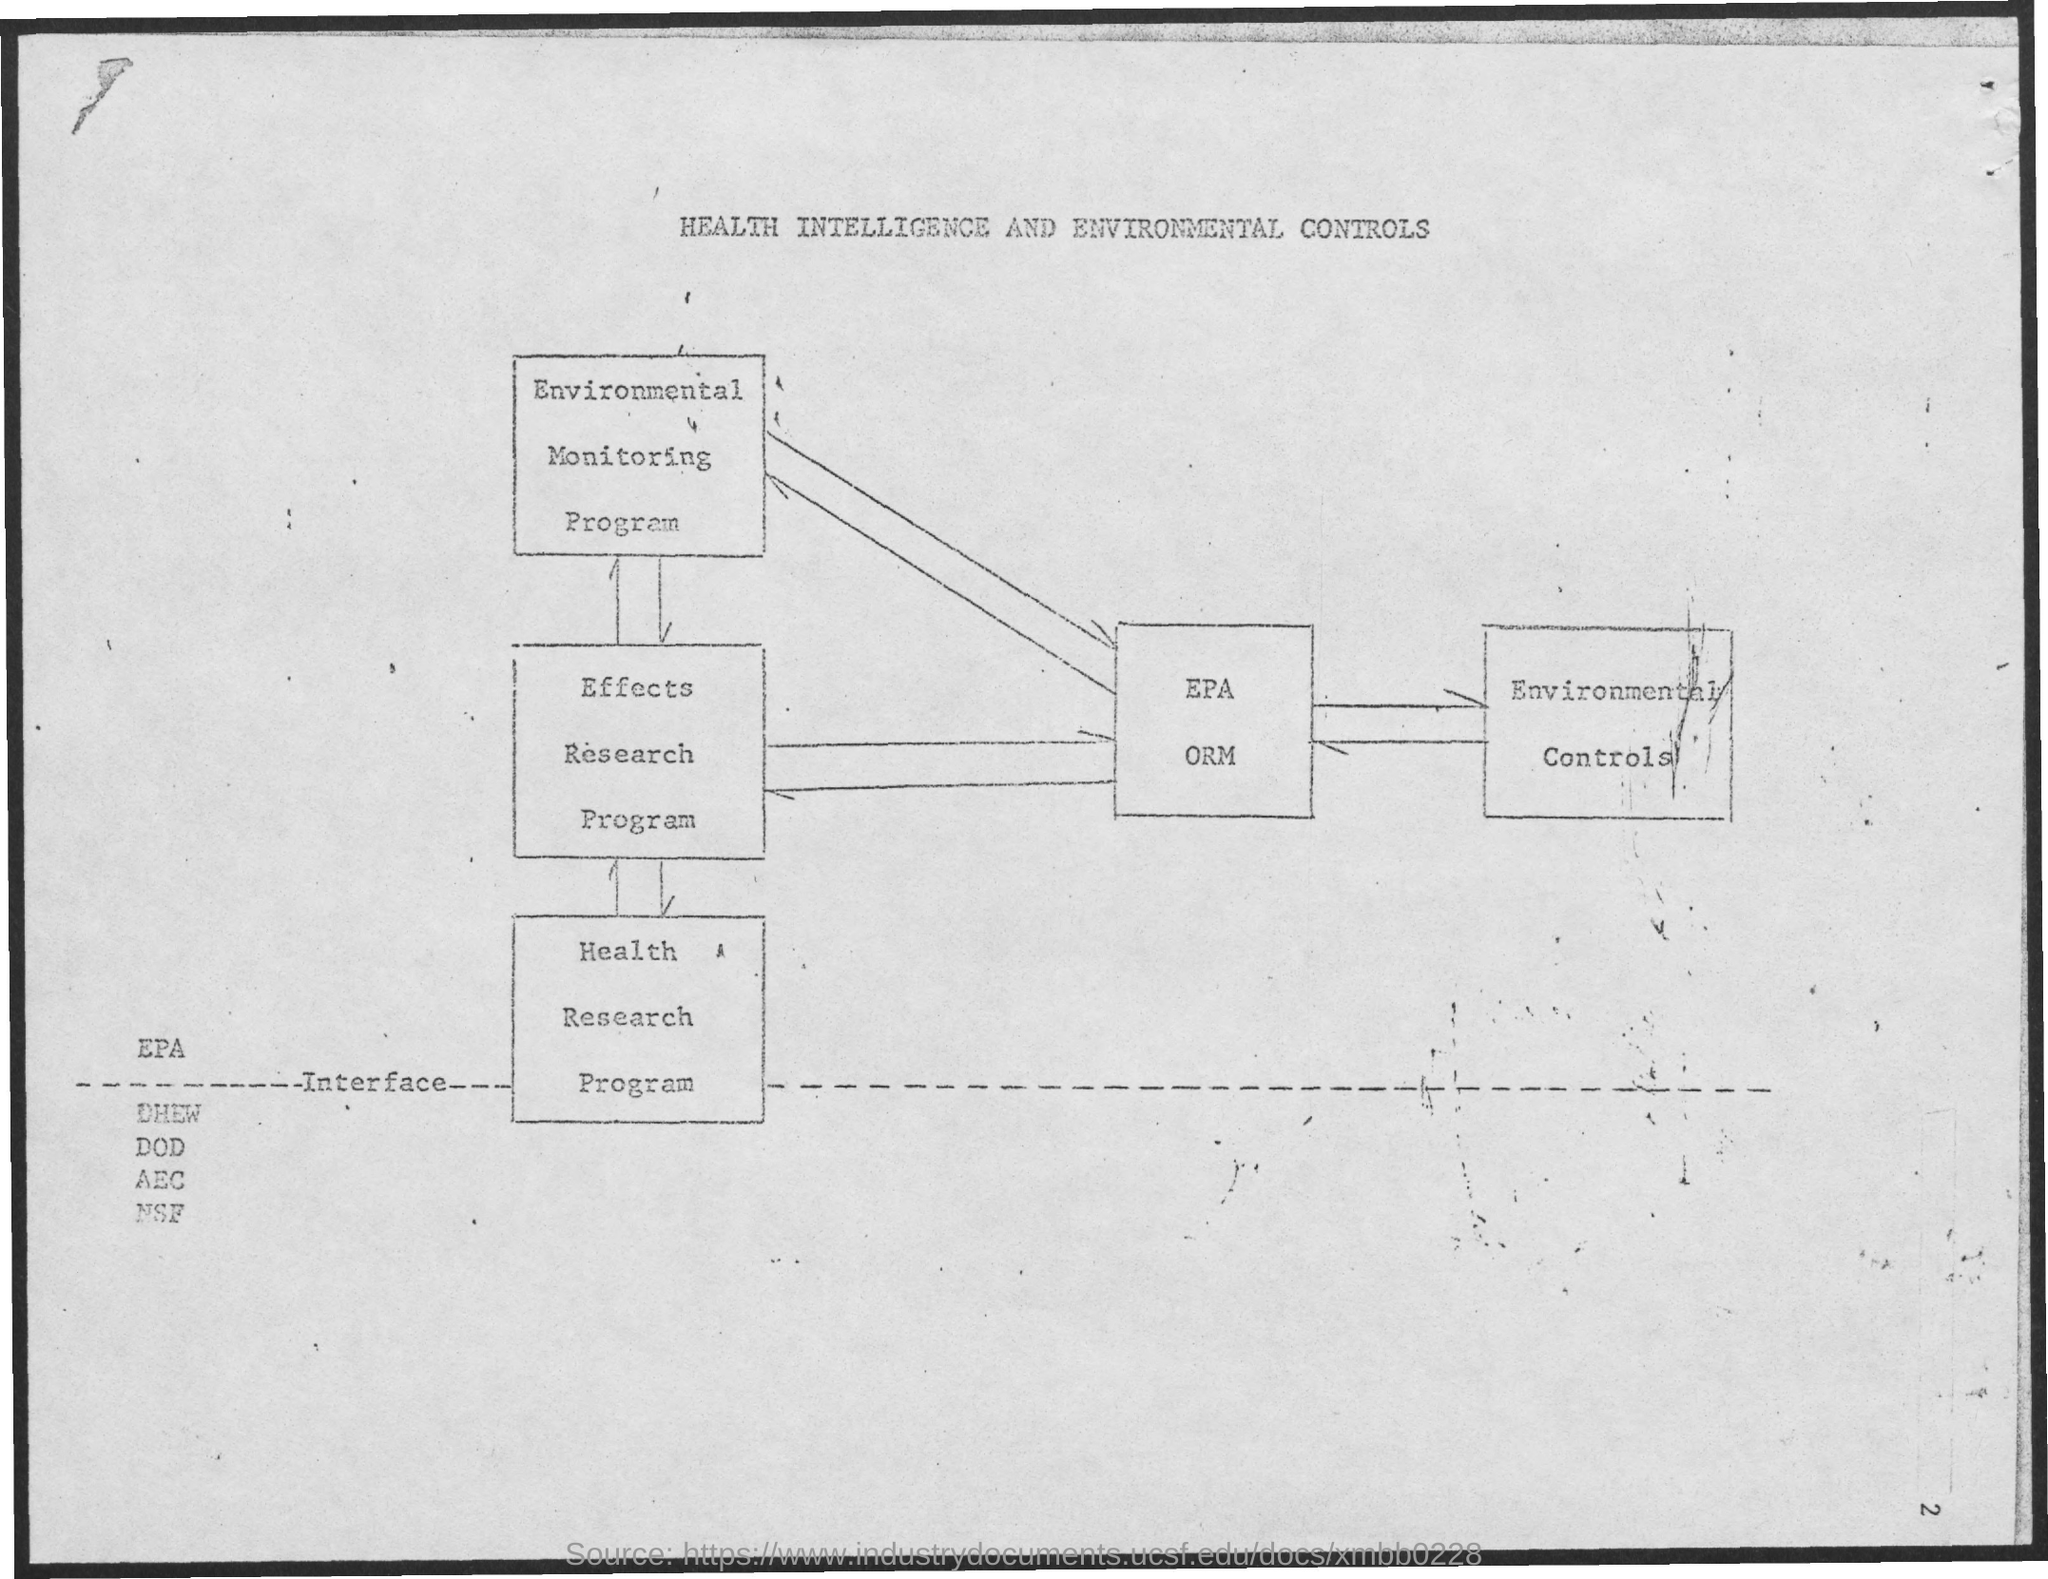What is the title of the document?
Your response must be concise. Health Intelligence and Environmental Controls. 